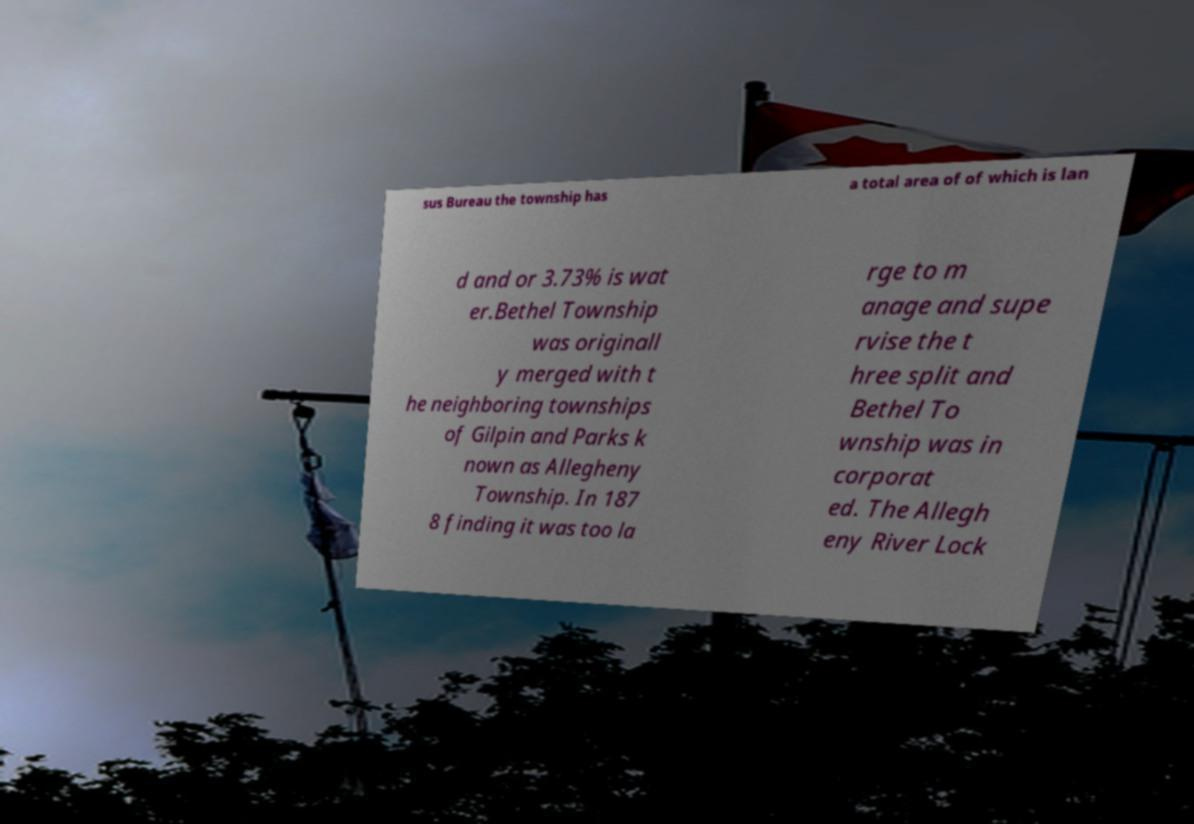Please identify and transcribe the text found in this image. sus Bureau the township has a total area of of which is lan d and or 3.73% is wat er.Bethel Township was originall y merged with t he neighboring townships of Gilpin and Parks k nown as Allegheny Township. In 187 8 finding it was too la rge to m anage and supe rvise the t hree split and Bethel To wnship was in corporat ed. The Allegh eny River Lock 